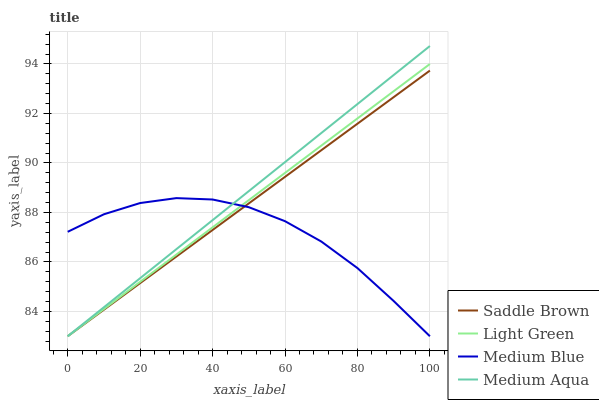Does Medium Blue have the minimum area under the curve?
Answer yes or no. Yes. Does Medium Aqua have the maximum area under the curve?
Answer yes or no. Yes. Does Saddle Brown have the minimum area under the curve?
Answer yes or no. No. Does Saddle Brown have the maximum area under the curve?
Answer yes or no. No. Is Light Green the smoothest?
Answer yes or no. Yes. Is Medium Blue the roughest?
Answer yes or no. Yes. Is Saddle Brown the smoothest?
Answer yes or no. No. Is Saddle Brown the roughest?
Answer yes or no. No. Does Medium Aqua have the lowest value?
Answer yes or no. Yes. Does Medium Aqua have the highest value?
Answer yes or no. Yes. Does Saddle Brown have the highest value?
Answer yes or no. No. Does Light Green intersect Saddle Brown?
Answer yes or no. Yes. Is Light Green less than Saddle Brown?
Answer yes or no. No. Is Light Green greater than Saddle Brown?
Answer yes or no. No. 